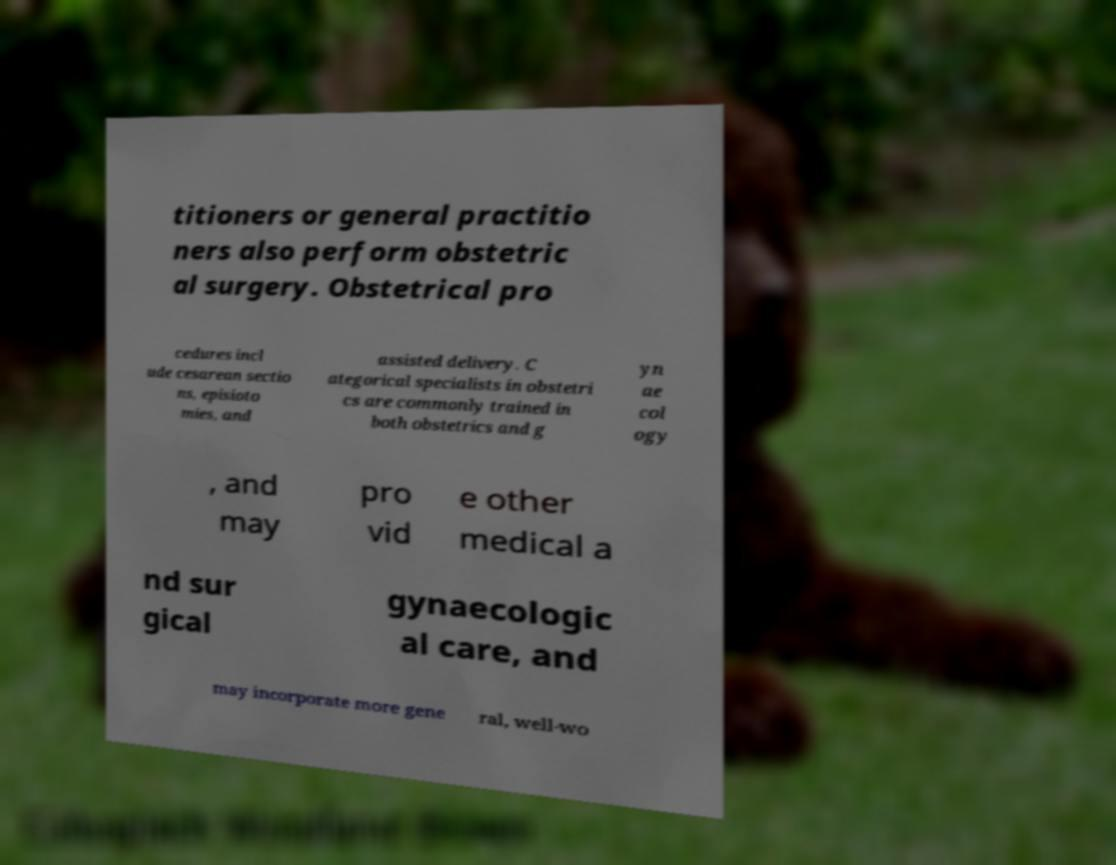Can you accurately transcribe the text from the provided image for me? titioners or general practitio ners also perform obstetric al surgery. Obstetrical pro cedures incl ude cesarean sectio ns, episioto mies, and assisted delivery. C ategorical specialists in obstetri cs are commonly trained in both obstetrics and g yn ae col ogy , and may pro vid e other medical a nd sur gical gynaecologic al care, and may incorporate more gene ral, well-wo 